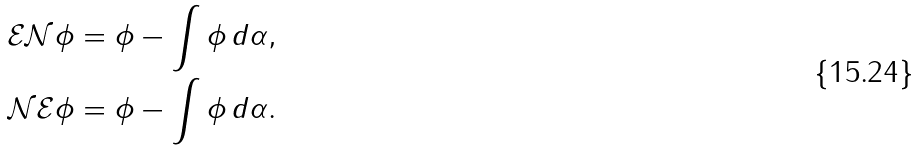<formula> <loc_0><loc_0><loc_500><loc_500>\mathcal { E } \mathcal { N } \phi & = \phi - \int \phi \, d \alpha , \\ \mathcal { N } \mathcal { E } \phi & = \phi - \int \phi \, d \alpha .</formula> 